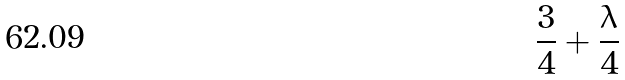Convert formula to latex. <formula><loc_0><loc_0><loc_500><loc_500>\frac { 3 } { 4 } + \frac { \lambda } { 4 }</formula> 